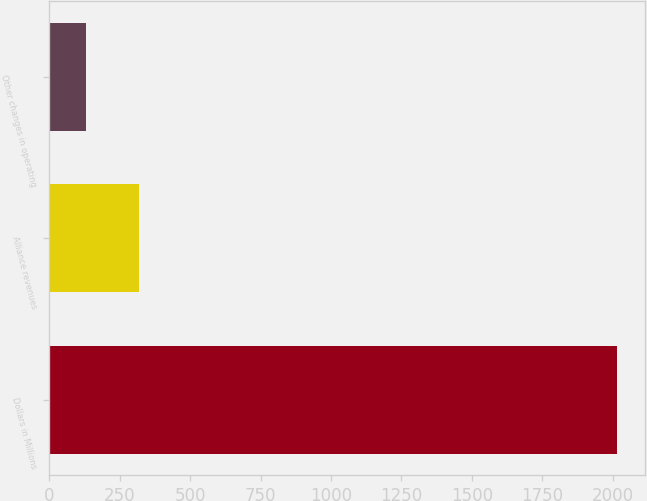<chart> <loc_0><loc_0><loc_500><loc_500><bar_chart><fcel>Dollars in Millions<fcel>Alliance revenues<fcel>Other changes in operating<nl><fcel>2015<fcel>317.6<fcel>129<nl></chart> 